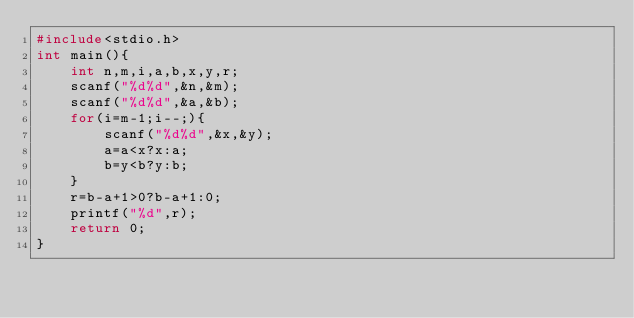<code> <loc_0><loc_0><loc_500><loc_500><_C_>#include<stdio.h>
int main(){
    int n,m,i,a,b,x,y,r;
    scanf("%d%d",&n,&m);
    scanf("%d%d",&a,&b);
    for(i=m-1;i--;){
        scanf("%d%d",&x,&y);
        a=a<x?x:a;
        b=y<b?y:b;
    }
    r=b-a+1>0?b-a+1:0;
    printf("%d",r);
    return 0;
}</code> 